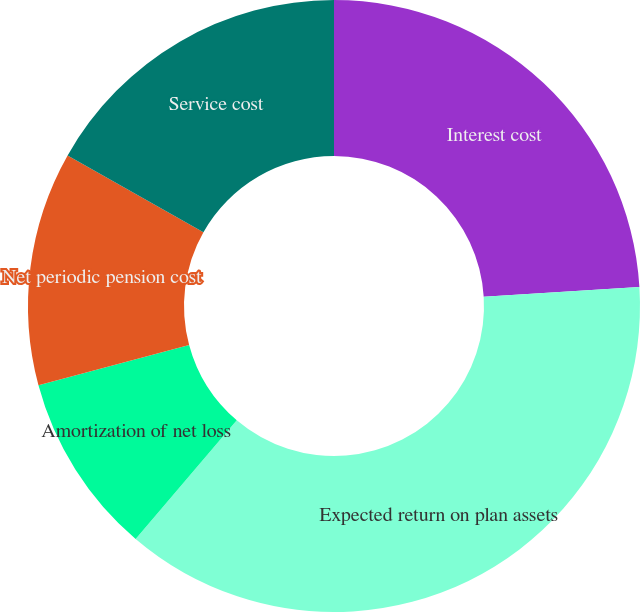<chart> <loc_0><loc_0><loc_500><loc_500><pie_chart><fcel>Interest cost<fcel>Expected return on plan assets<fcel>Amortization of net loss<fcel>Net periodic pension cost<fcel>Service cost<nl><fcel>24.01%<fcel>37.21%<fcel>9.6%<fcel>12.36%<fcel>16.81%<nl></chart> 